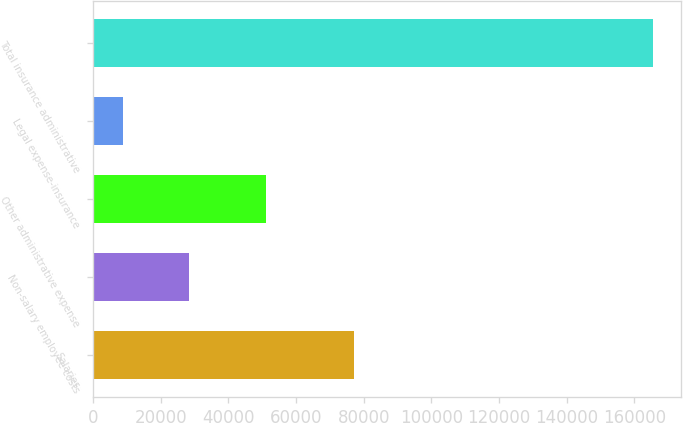Convert chart. <chart><loc_0><loc_0><loc_500><loc_500><bar_chart><fcel>Salaries<fcel>Non-salary employee costs<fcel>Other administrative expense<fcel>Legal expense-insurance<fcel>Total insurance administrative<nl><fcel>77137<fcel>28344<fcel>51228<fcel>8696<fcel>165405<nl></chart> 